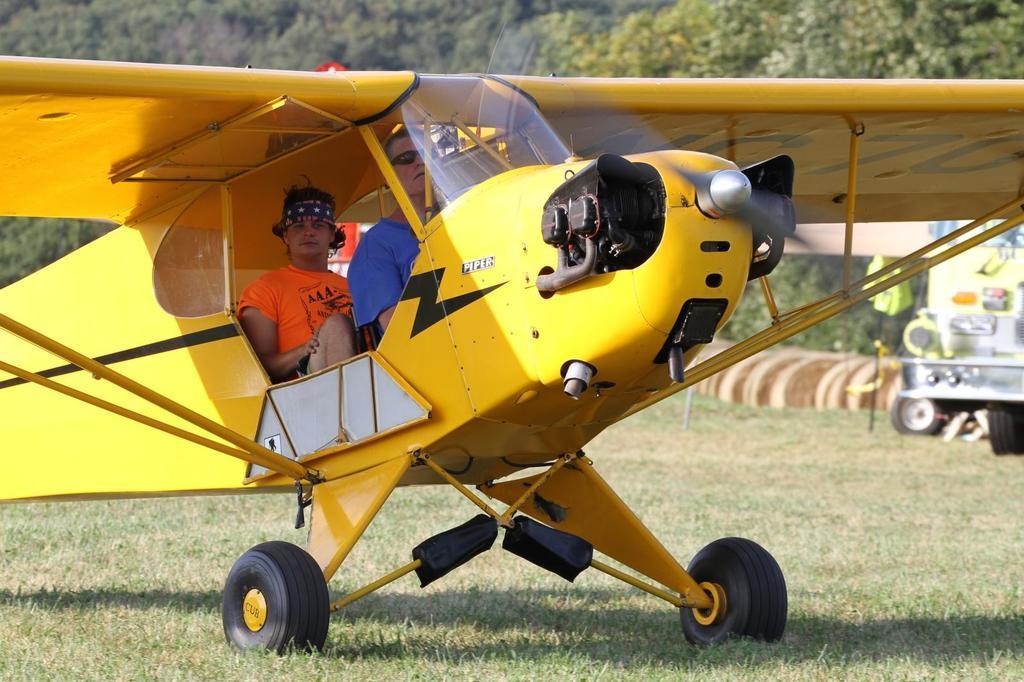Could you give a brief overview of what you see in this image? In this image I can see an open grass ground and on it I can see yellow colour aircraft. Here I can see two men are sitting. In the background I can see number of trees. 